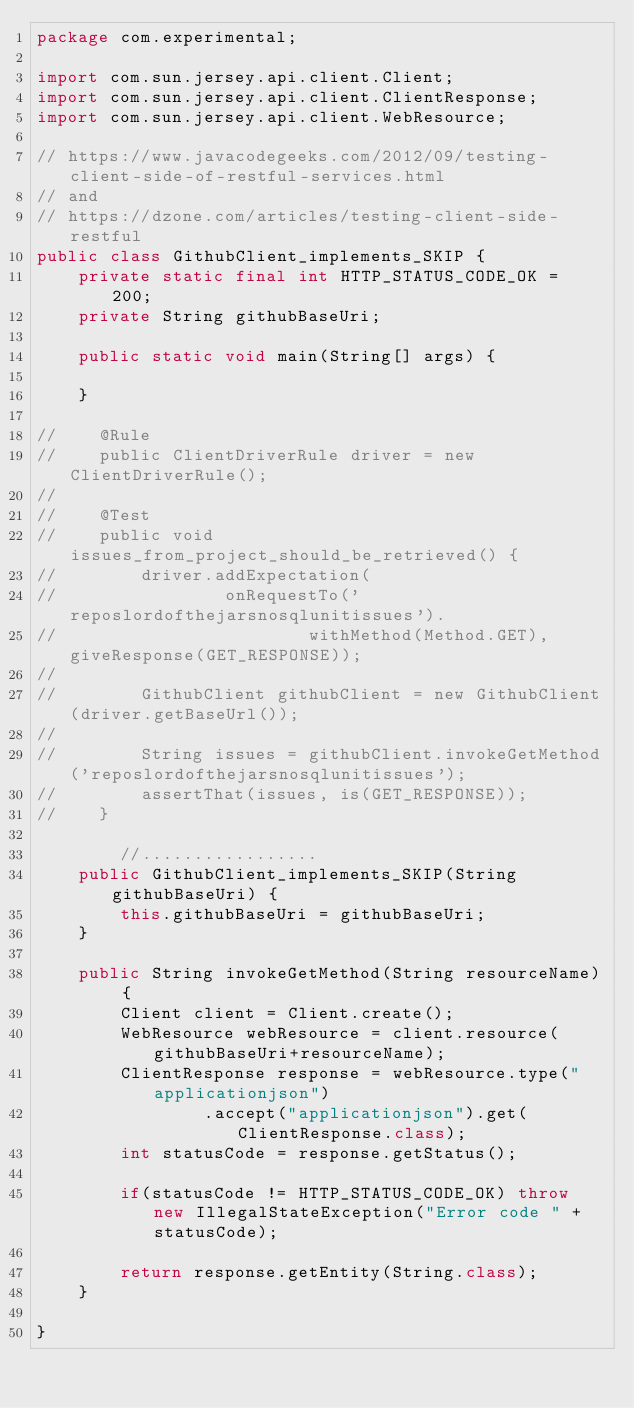<code> <loc_0><loc_0><loc_500><loc_500><_Java_>package com.experimental;

import com.sun.jersey.api.client.Client;
import com.sun.jersey.api.client.ClientResponse;
import com.sun.jersey.api.client.WebResource;

// https://www.javacodegeeks.com/2012/09/testing-client-side-of-restful-services.html
// and
// https://dzone.com/articles/testing-client-side-restful
public class GithubClient_implements_SKIP {
    private static final int HTTP_STATUS_CODE_OK = 200;
    private String githubBaseUri;

    public static void main(String[] args) {

    }

//    @Rule
//    public ClientDriverRule driver = new ClientDriverRule();
//
//    @Test
//    public void issues_from_project_should_be_retrieved() {
//        driver.addExpectation(
//                onRequestTo('reposlordofthejarsnosqlunitissues').
//                        withMethod(Method.GET), giveResponse(GET_RESPONSE));
//
//        GithubClient githubClient = new GithubClient(driver.getBaseUrl());
//
//        String issues = githubClient.invokeGetMethod('reposlordofthejarsnosqlunitissues');
//        assertThat(issues, is(GET_RESPONSE));
//    }

        //.................
    public GithubClient_implements_SKIP(String githubBaseUri) {
        this.githubBaseUri = githubBaseUri;
    }

    public String invokeGetMethod(String resourceName) {
        Client client = Client.create();
        WebResource webResource = client.resource(githubBaseUri+resourceName);
        ClientResponse response = webResource.type("applicationjson")
                .accept("applicationjson").get(ClientResponse.class);
        int statusCode = response.getStatus();

        if(statusCode != HTTP_STATUS_CODE_OK) throw new IllegalStateException("Error code " +statusCode);

        return response.getEntity(String.class);
    }

}</code> 